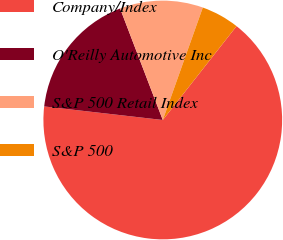Convert chart. <chart><loc_0><loc_0><loc_500><loc_500><pie_chart><fcel>Company/Index<fcel>O'Reilly Automotive Inc<fcel>S&P 500 Retail Index<fcel>S&P 500<nl><fcel>66.21%<fcel>17.37%<fcel>11.26%<fcel>5.16%<nl></chart> 